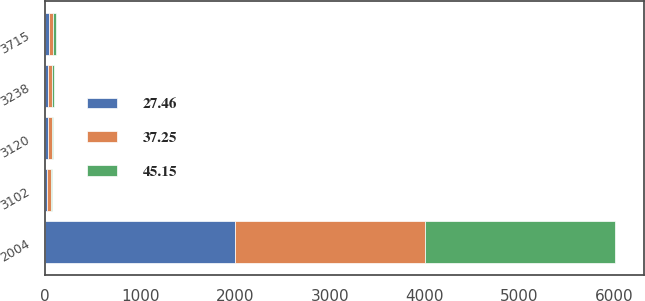<chart> <loc_0><loc_0><loc_500><loc_500><stacked_bar_chart><ecel><fcel>2004<fcel>3102<fcel>3120<fcel>3238<fcel>3715<nl><fcel>37.25<fcel>2004<fcel>39.96<fcel>39.65<fcel>39.9<fcel>45.15<nl><fcel>45.15<fcel>2003<fcel>15.71<fcel>18.11<fcel>22.66<fcel>27.46<nl><fcel>27.46<fcel>2003<fcel>19.63<fcel>27<fcel>31<fcel>37.25<nl></chart> 